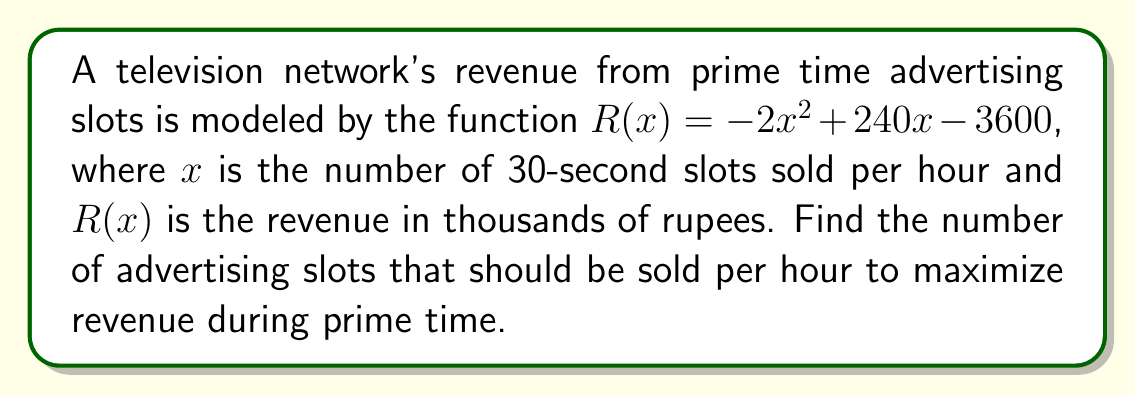Give your solution to this math problem. To find the maximum revenue point, we need to follow these steps:

1) The revenue function $R(x)$ is a quadratic function. The maximum point occurs at the vertex of the parabola.

2) For a quadratic function in the form $f(x) = ax^2 + bx + c$, the x-coordinate of the vertex is given by $x = -\frac{b}{2a}$.

3) In our case, $a = -2$, $b = 240$, and $c = -3600$.

4) Substituting these values into the vertex formula:

   $x = -\frac{240}{2(-2)} = -\frac{240}{-4} = 60$

5) To verify this is a maximum (not a minimum), we can check that $a < 0$, which it is ($a = -2$).

6) Therefore, the revenue is maximized when 60 advertising slots are sold per hour.

7) We can calculate the maximum revenue by substituting $x = 60$ into the original function:

   $R(60) = -2(60)^2 + 240(60) - 3600$
   $= -2(3600) + 14400 - 3600$
   $= -7200 + 14400 - 3600$
   $= 3600$

   So the maximum revenue is 3,600,000 rupees.
Answer: 60 advertising slots per hour 